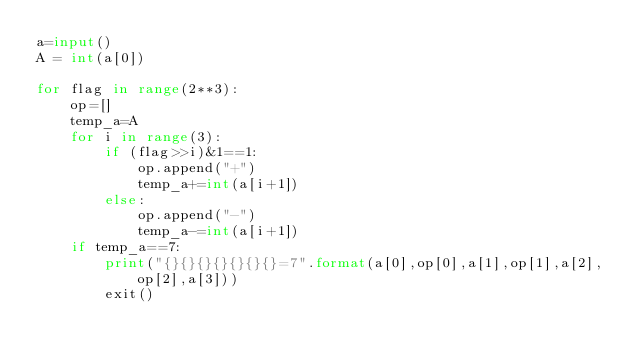Convert code to text. <code><loc_0><loc_0><loc_500><loc_500><_Python_>a=input()
A = int(a[0])

for flag in range(2**3):
	op=[]
	temp_a=A
	for i in range(3):
		if (flag>>i)&1==1:
			op.append("+")
			temp_a+=int(a[i+1])
		else:
			op.append("-")
			temp_a-=int(a[i+1])
	if temp_a==7:
		print("{}{}{}{}{}{}{}=7".format(a[0],op[0],a[1],op[1],a[2],op[2],a[3]))
		exit()
</code> 